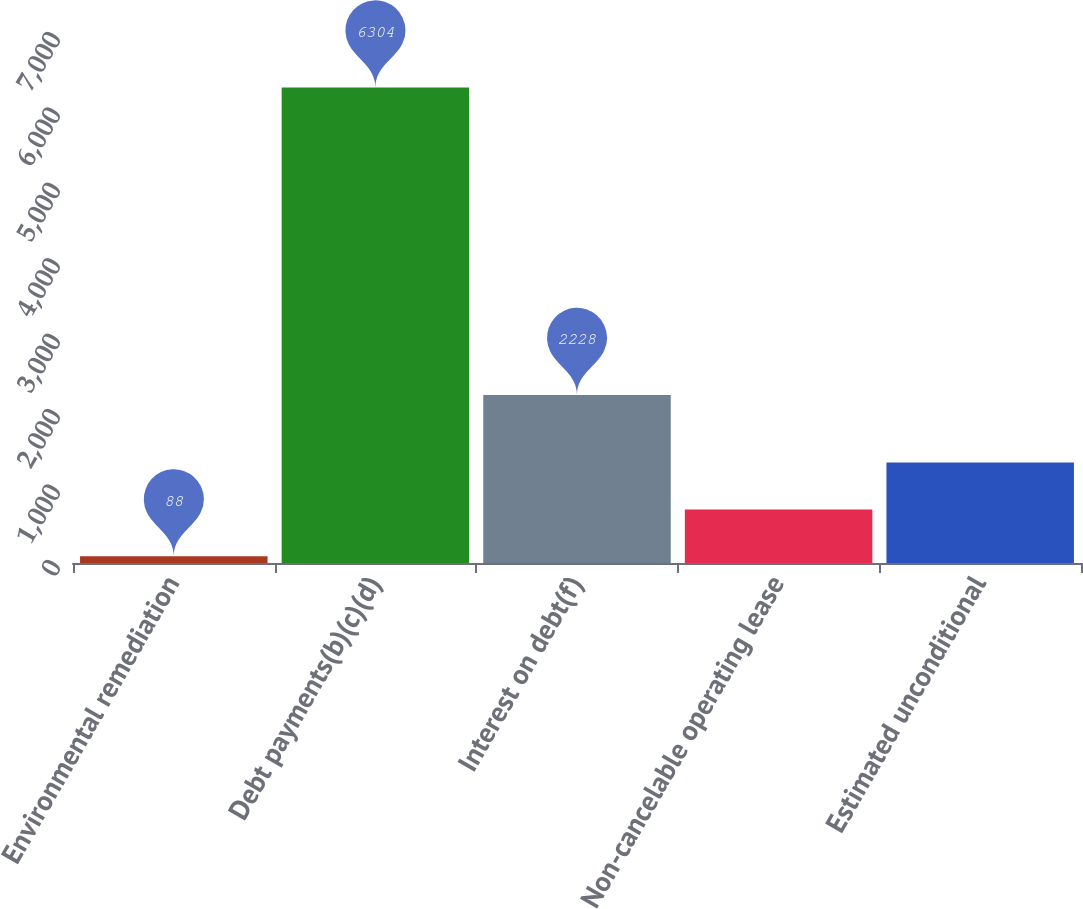Convert chart. <chart><loc_0><loc_0><loc_500><loc_500><bar_chart><fcel>Environmental remediation<fcel>Debt payments(b)(c)(d)<fcel>Interest on debt(f)<fcel>Non-cancelable operating lease<fcel>Estimated unconditional<nl><fcel>88<fcel>6304<fcel>2228<fcel>709.6<fcel>1331.2<nl></chart> 